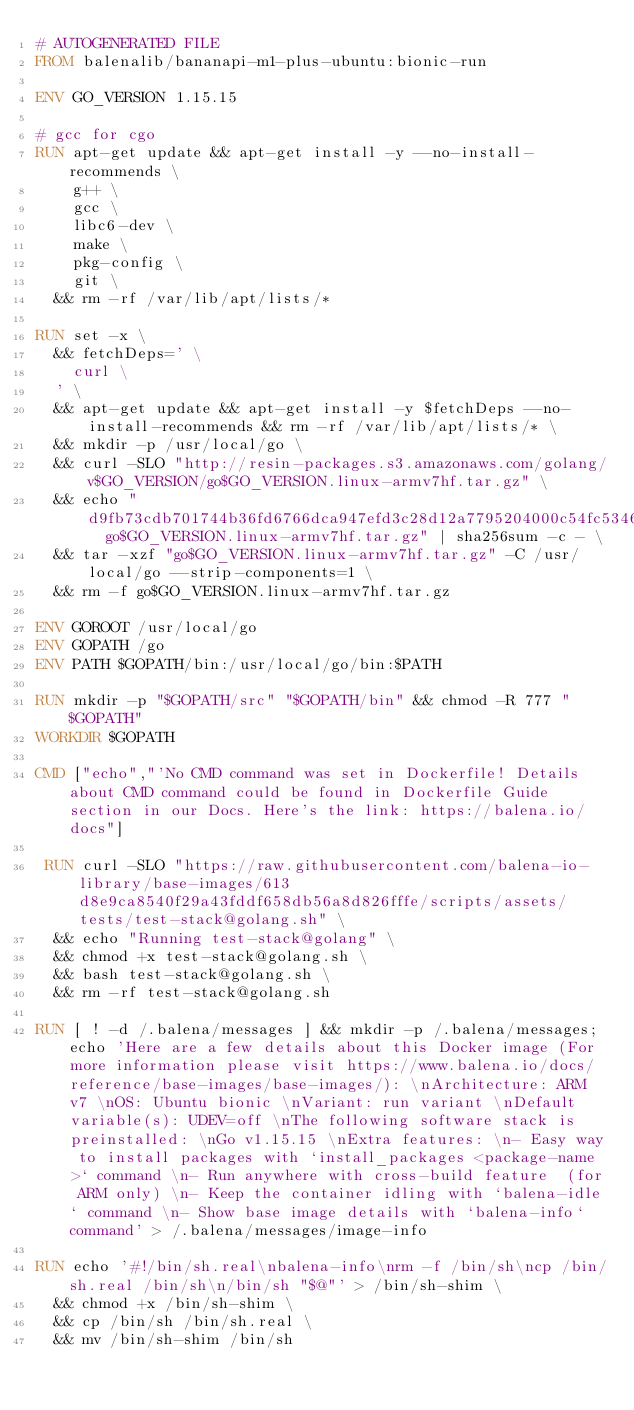Convert code to text. <code><loc_0><loc_0><loc_500><loc_500><_Dockerfile_># AUTOGENERATED FILE
FROM balenalib/bananapi-m1-plus-ubuntu:bionic-run

ENV GO_VERSION 1.15.15

# gcc for cgo
RUN apt-get update && apt-get install -y --no-install-recommends \
		g++ \
		gcc \
		libc6-dev \
		make \
		pkg-config \
		git \
	&& rm -rf /var/lib/apt/lists/*

RUN set -x \
	&& fetchDeps=' \
		curl \
	' \
	&& apt-get update && apt-get install -y $fetchDeps --no-install-recommends && rm -rf /var/lib/apt/lists/* \
	&& mkdir -p /usr/local/go \
	&& curl -SLO "http://resin-packages.s3.amazonaws.com/golang/v$GO_VERSION/go$GO_VERSION.linux-armv7hf.tar.gz" \
	&& echo "d9fb73cdb701744b36fd6766dca947efd3c28d12a7795204000c54fc53464dde  go$GO_VERSION.linux-armv7hf.tar.gz" | sha256sum -c - \
	&& tar -xzf "go$GO_VERSION.linux-armv7hf.tar.gz" -C /usr/local/go --strip-components=1 \
	&& rm -f go$GO_VERSION.linux-armv7hf.tar.gz

ENV GOROOT /usr/local/go
ENV GOPATH /go
ENV PATH $GOPATH/bin:/usr/local/go/bin:$PATH

RUN mkdir -p "$GOPATH/src" "$GOPATH/bin" && chmod -R 777 "$GOPATH"
WORKDIR $GOPATH

CMD ["echo","'No CMD command was set in Dockerfile! Details about CMD command could be found in Dockerfile Guide section in our Docs. Here's the link: https://balena.io/docs"]

 RUN curl -SLO "https://raw.githubusercontent.com/balena-io-library/base-images/613d8e9ca8540f29a43fddf658db56a8d826fffe/scripts/assets/tests/test-stack@golang.sh" \
  && echo "Running test-stack@golang" \
  && chmod +x test-stack@golang.sh \
  && bash test-stack@golang.sh \
  && rm -rf test-stack@golang.sh 

RUN [ ! -d /.balena/messages ] && mkdir -p /.balena/messages; echo 'Here are a few details about this Docker image (For more information please visit https://www.balena.io/docs/reference/base-images/base-images/): \nArchitecture: ARM v7 \nOS: Ubuntu bionic \nVariant: run variant \nDefault variable(s): UDEV=off \nThe following software stack is preinstalled: \nGo v1.15.15 \nExtra features: \n- Easy way to install packages with `install_packages <package-name>` command \n- Run anywhere with cross-build feature  (for ARM only) \n- Keep the container idling with `balena-idle` command \n- Show base image details with `balena-info` command' > /.balena/messages/image-info

RUN echo '#!/bin/sh.real\nbalena-info\nrm -f /bin/sh\ncp /bin/sh.real /bin/sh\n/bin/sh "$@"' > /bin/sh-shim \
	&& chmod +x /bin/sh-shim \
	&& cp /bin/sh /bin/sh.real \
	&& mv /bin/sh-shim /bin/sh</code> 